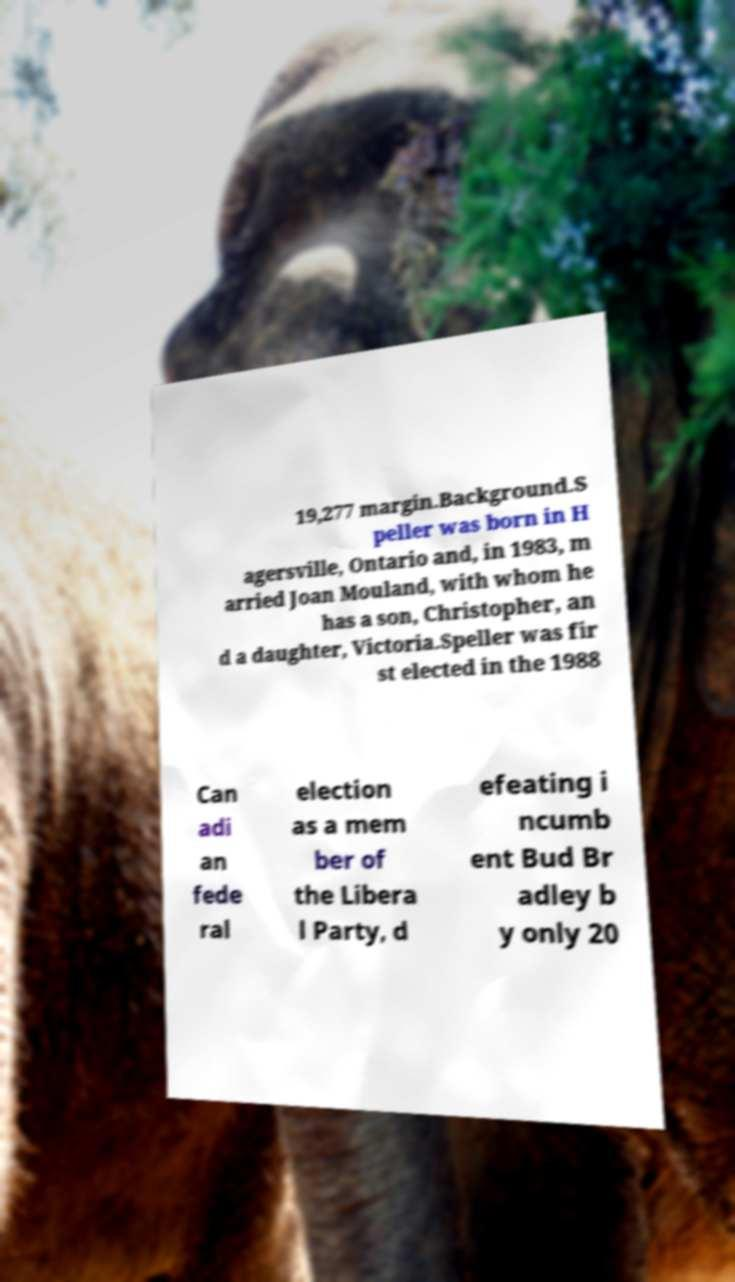I need the written content from this picture converted into text. Can you do that? 19,277 margin.Background.S peller was born in H agersville, Ontario and, in 1983, m arried Joan Mouland, with whom he has a son, Christopher, an d a daughter, Victoria.Speller was fir st elected in the 1988 Can adi an fede ral election as a mem ber of the Libera l Party, d efeating i ncumb ent Bud Br adley b y only 20 